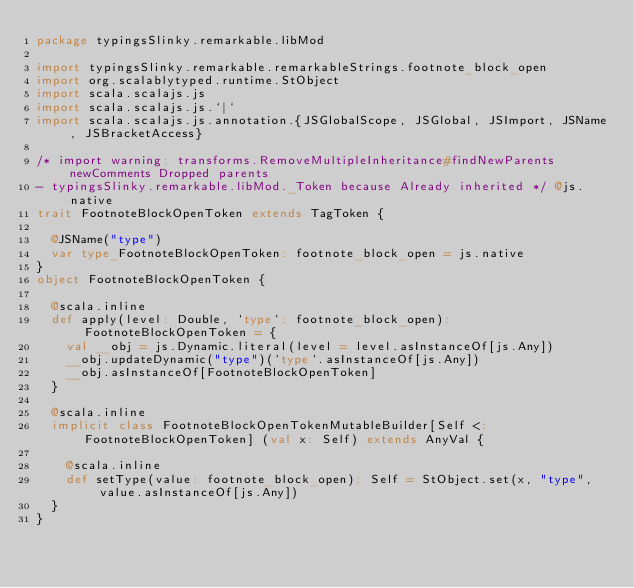<code> <loc_0><loc_0><loc_500><loc_500><_Scala_>package typingsSlinky.remarkable.libMod

import typingsSlinky.remarkable.remarkableStrings.footnote_block_open
import org.scalablytyped.runtime.StObject
import scala.scalajs.js
import scala.scalajs.js.`|`
import scala.scalajs.js.annotation.{JSGlobalScope, JSGlobal, JSImport, JSName, JSBracketAccess}

/* import warning: transforms.RemoveMultipleInheritance#findNewParents newComments Dropped parents 
- typingsSlinky.remarkable.libMod._Token because Already inherited */ @js.native
trait FootnoteBlockOpenToken extends TagToken {
  
  @JSName("type")
  var type_FootnoteBlockOpenToken: footnote_block_open = js.native
}
object FootnoteBlockOpenToken {
  
  @scala.inline
  def apply(level: Double, `type`: footnote_block_open): FootnoteBlockOpenToken = {
    val __obj = js.Dynamic.literal(level = level.asInstanceOf[js.Any])
    __obj.updateDynamic("type")(`type`.asInstanceOf[js.Any])
    __obj.asInstanceOf[FootnoteBlockOpenToken]
  }
  
  @scala.inline
  implicit class FootnoteBlockOpenTokenMutableBuilder[Self <: FootnoteBlockOpenToken] (val x: Self) extends AnyVal {
    
    @scala.inline
    def setType(value: footnote_block_open): Self = StObject.set(x, "type", value.asInstanceOf[js.Any])
  }
}
</code> 